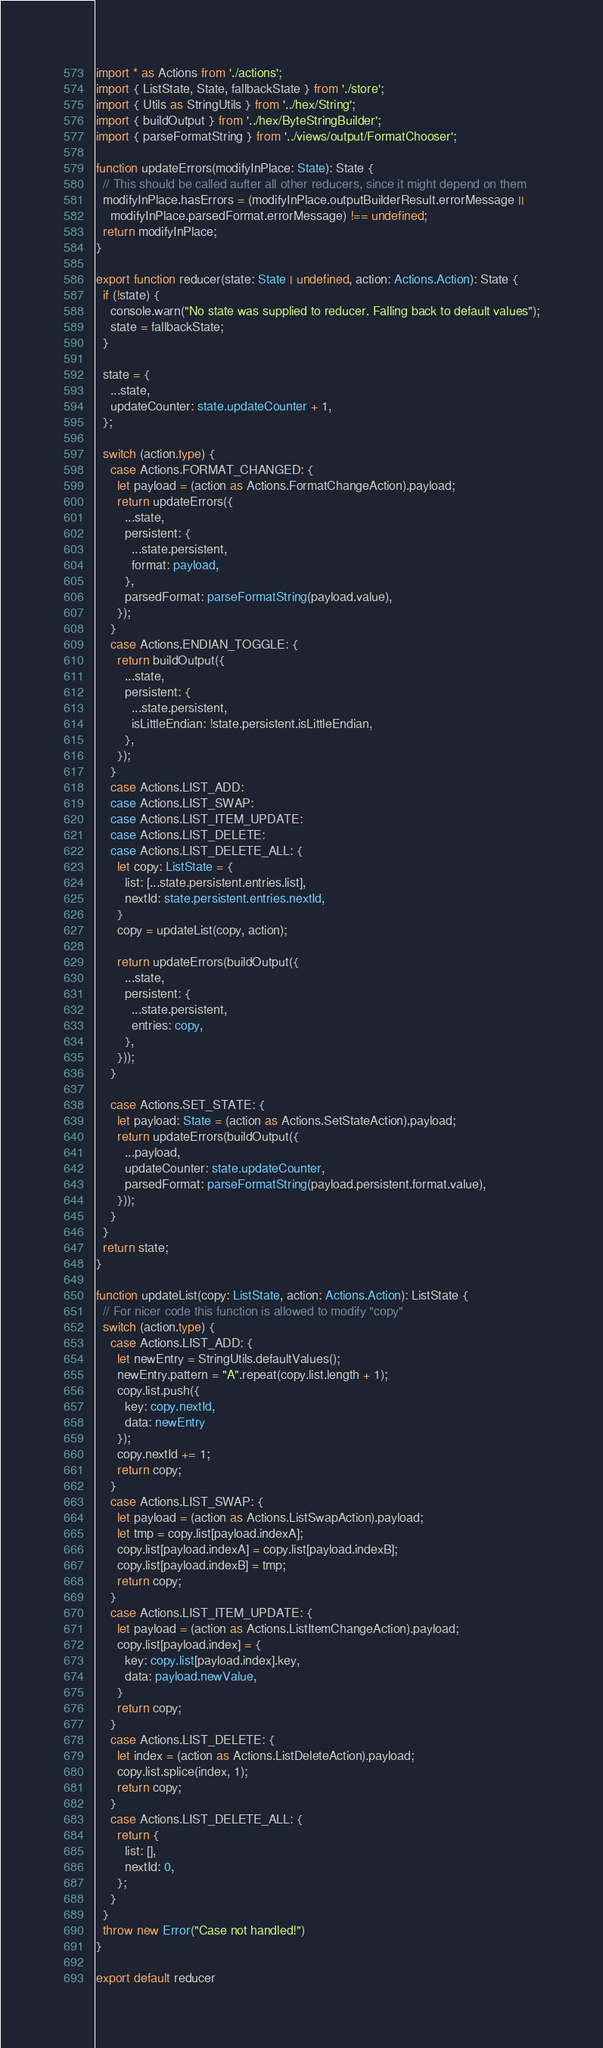<code> <loc_0><loc_0><loc_500><loc_500><_TypeScript_>import * as Actions from './actions';
import { ListState, State, fallbackState } from './store';
import { Utils as StringUtils } from '../hex/String';
import { buildOutput } from '../hex/ByteStringBuilder';
import { parseFormatString } from '../views/output/FormatChooser';

function updateErrors(modifyInPlace: State): State {
  // This should be called aufter all other reducers, since it might depend on them
  modifyInPlace.hasErrors = (modifyInPlace.outputBuilderResult.errorMessage ||
    modifyInPlace.parsedFormat.errorMessage) !== undefined;
  return modifyInPlace;
}

export function reducer(state: State | undefined, action: Actions.Action): State {
  if (!state) {
    console.warn("No state was supplied to reducer. Falling back to default values");
    state = fallbackState;
  }

  state = {
    ...state,
    updateCounter: state.updateCounter + 1,
  };

  switch (action.type) {
    case Actions.FORMAT_CHANGED: {
      let payload = (action as Actions.FormatChangeAction).payload;
      return updateErrors({
        ...state,
        persistent: {
          ...state.persistent,
          format: payload,
        },
        parsedFormat: parseFormatString(payload.value),
      });
    }
    case Actions.ENDIAN_TOGGLE: {
      return buildOutput({
        ...state,
        persistent: {
          ...state.persistent,
          isLittleEndian: !state.persistent.isLittleEndian,
        },
      });
    }
    case Actions.LIST_ADD:
    case Actions.LIST_SWAP:
    case Actions.LIST_ITEM_UPDATE:
    case Actions.LIST_DELETE:
    case Actions.LIST_DELETE_ALL: {
      let copy: ListState = {
        list: [...state.persistent.entries.list],
        nextId: state.persistent.entries.nextId,
      }
      copy = updateList(copy, action);

      return updateErrors(buildOutput({
        ...state,
        persistent: {
          ...state.persistent,
          entries: copy,
        },
      }));
    }

    case Actions.SET_STATE: {
      let payload: State = (action as Actions.SetStateAction).payload;
      return updateErrors(buildOutput({
        ...payload,
        updateCounter: state.updateCounter,
        parsedFormat: parseFormatString(payload.persistent.format.value),
      }));
    }
  }
  return state;
}

function updateList(copy: ListState, action: Actions.Action): ListState {
  // For nicer code this function is allowed to modify "copy"
  switch (action.type) {
    case Actions.LIST_ADD: {
      let newEntry = StringUtils.defaultValues();
      newEntry.pattern = "A".repeat(copy.list.length + 1);
      copy.list.push({
        key: copy.nextId,
        data: newEntry
      });
      copy.nextId += 1;
      return copy;
    }
    case Actions.LIST_SWAP: {
      let payload = (action as Actions.ListSwapAction).payload;
      let tmp = copy.list[payload.indexA];
      copy.list[payload.indexA] = copy.list[payload.indexB];
      copy.list[payload.indexB] = tmp;
      return copy;
    }
    case Actions.LIST_ITEM_UPDATE: {
      let payload = (action as Actions.ListItemChangeAction).payload;
      copy.list[payload.index] = {
        key: copy.list[payload.index].key,
        data: payload.newValue,
      }
      return copy;
    }
    case Actions.LIST_DELETE: {
      let index = (action as Actions.ListDeleteAction).payload;
      copy.list.splice(index, 1);
      return copy;
    }
    case Actions.LIST_DELETE_ALL: {
      return {
        list: [],
        nextId: 0,
      };
    }
  }
  throw new Error("Case not handled!")
}

export default reducer
</code> 